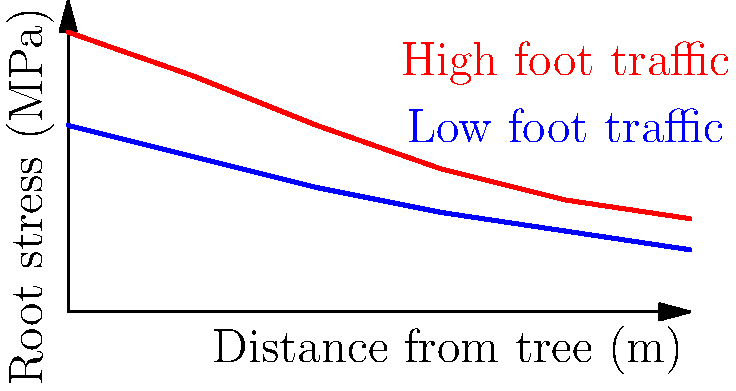Based on the graph showing root stress in relation to distance from a tree under different foot traffic conditions in a national park, calculate the percentage increase in root stress at 4 meters from the tree when foot traffic is high compared to low. Round your answer to the nearest whole percent. To solve this problem, we need to follow these steps:

1. Identify the root stress values at 4 meters for both high and low foot traffic:
   - High foot traffic (red line): $3.0$ MPa
   - Low foot traffic (blue line): $2.0$ MPa

2. Calculate the difference in stress:
   $3.0 \text{ MPa} - 2.0 \text{ MPa} = 1.0 \text{ MPa}$

3. Calculate the percentage increase:
   Percentage increase = $\frac{\text{Increase}}{\text{Original Value}} \times 100\%$
   
   $= \frac{1.0 \text{ MPa}}{2.0 \text{ MPa}} \times 100\%$
   
   $= 0.5 \times 100\%$
   
   $= 50\%$

4. Round to the nearest whole percent:
   The result is already a whole number, so no rounding is necessary.

Therefore, the root stress at 4 meters from the tree increases by 50% under high foot traffic conditions compared to low foot traffic.
Answer: 50% 